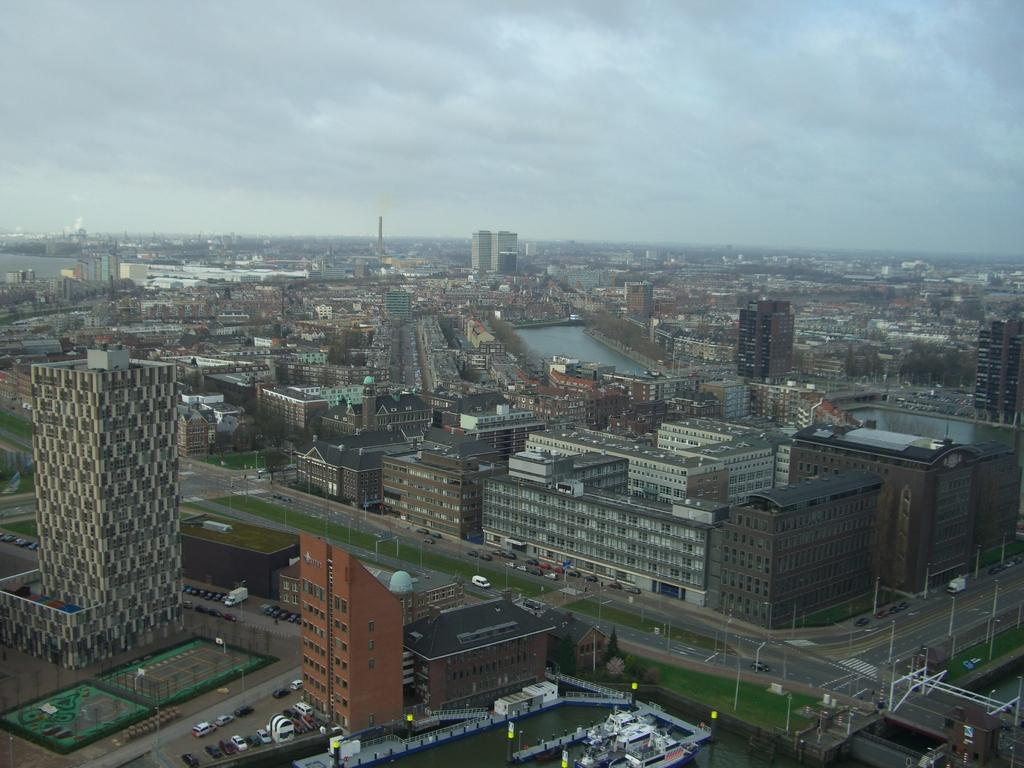What type of location is depicted in the image? The image depicts a city. What structures can be seen in the city? There are buildings in the image. What architectural features are visible on the buildings? Windows are visible in the image. What are the poles used for in the image? The purpose of the poles is not specified, but they are likely used for streetlights or other urban infrastructure. What mode of transportation can be seen on the road in the image? Vehicles are present on the road in the image. What type of natural environment is visible in the image? There is grass and water visible in the image. What is visible in the sky in the image? Clouds are present in the sky in the image. What type of stone is used to create the veil in the image? There is no veil present in the image; it depicts a city with various urban elements and natural features. 